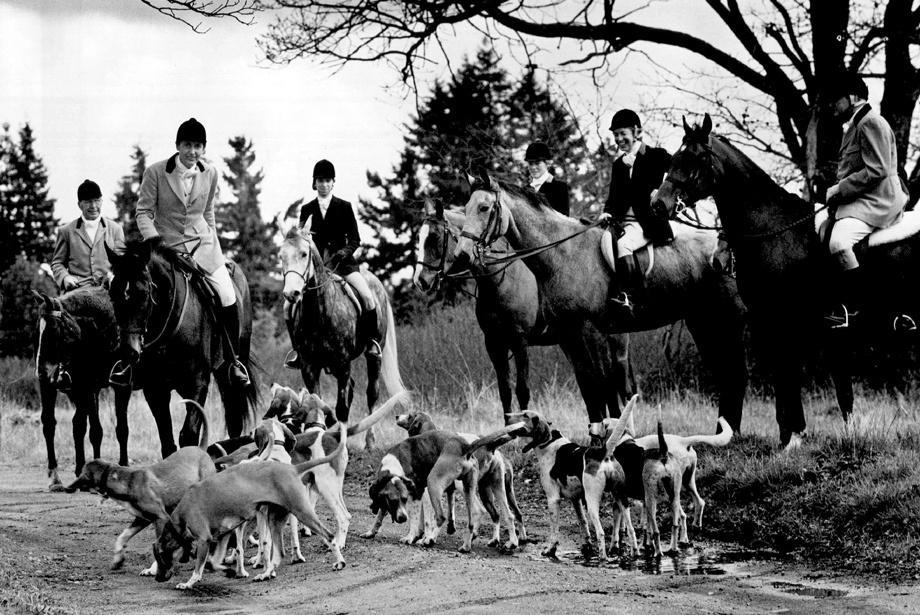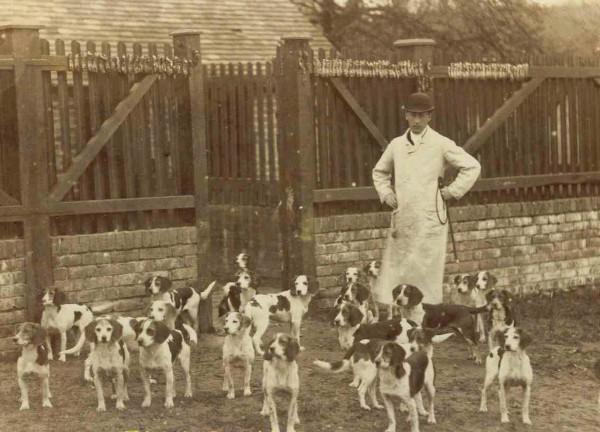The first image is the image on the left, the second image is the image on the right. Examine the images to the left and right. Is the description "In one image, fox hunters are on horses with a pack of hounds." accurate? Answer yes or no. Yes. 